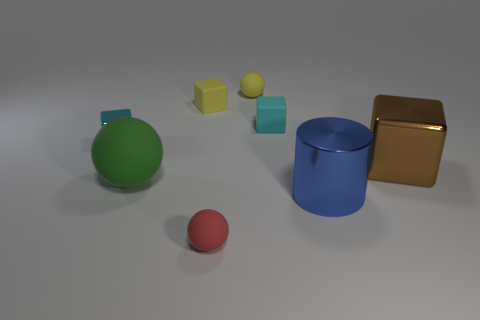Add 1 cyan things. How many objects exist? 9 Subtract all red balls. How many balls are left? 2 Subtract 3 blocks. How many blocks are left? 1 Subtract all green cylinders. Subtract all purple spheres. How many cylinders are left? 1 Subtract all green blocks. How many yellow balls are left? 1 Subtract all large cyan matte cylinders. Subtract all metal cylinders. How many objects are left? 7 Add 7 tiny red things. How many tiny red things are left? 8 Add 4 small gray rubber objects. How many small gray rubber objects exist? 4 Subtract all yellow cubes. How many cubes are left? 3 Subtract 0 gray spheres. How many objects are left? 8 